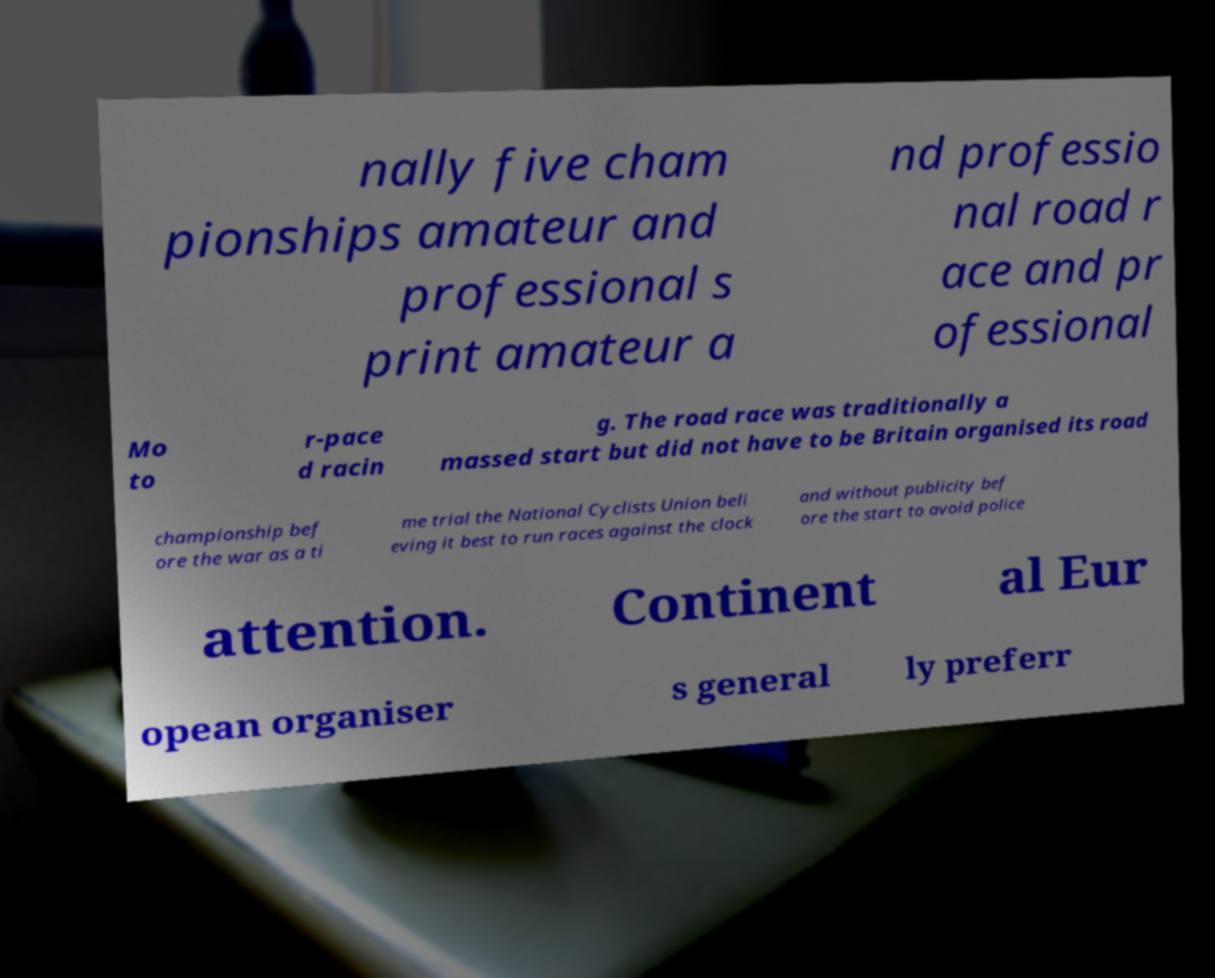Please identify and transcribe the text found in this image. nally five cham pionships amateur and professional s print amateur a nd professio nal road r ace and pr ofessional Mo to r-pace d racin g. The road race was traditionally a massed start but did not have to be Britain organised its road championship bef ore the war as a ti me trial the National Cyclists Union beli eving it best to run races against the clock and without publicity bef ore the start to avoid police attention. Continent al Eur opean organiser s general ly preferr 